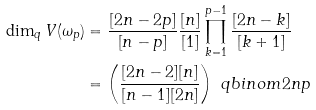<formula> <loc_0><loc_0><loc_500><loc_500>\dim _ { q } V ( \omega _ { p } ) & = \frac { [ 2 n - 2 p ] } { [ n - p ] } \frac { [ n ] } { [ 1 ] } \prod _ { k = 1 } ^ { p - 1 } \frac { [ 2 n - k ] } { [ k + 1 ] } \\ & = \left ( \frac { [ 2 n - 2 ] [ n ] } { [ n - 1 ] [ 2 n ] } \right ) \ q b i n o m { 2 n } { p }</formula> 